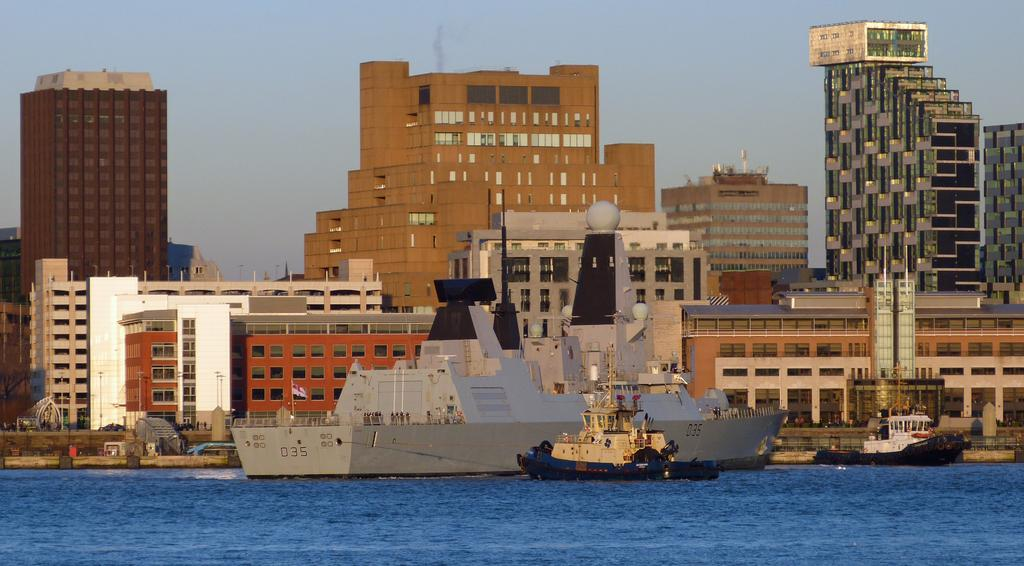What is the main subject of the image? The main subject of the image is ships. Where are the ships located in the image? The ships are on the water. What can be seen in the background of the image? There are buildings and the sky visible in the background of the image. What type of school can be seen in the image? There is no school present in the image; it features ships on the water with buildings and the sky in the background. 